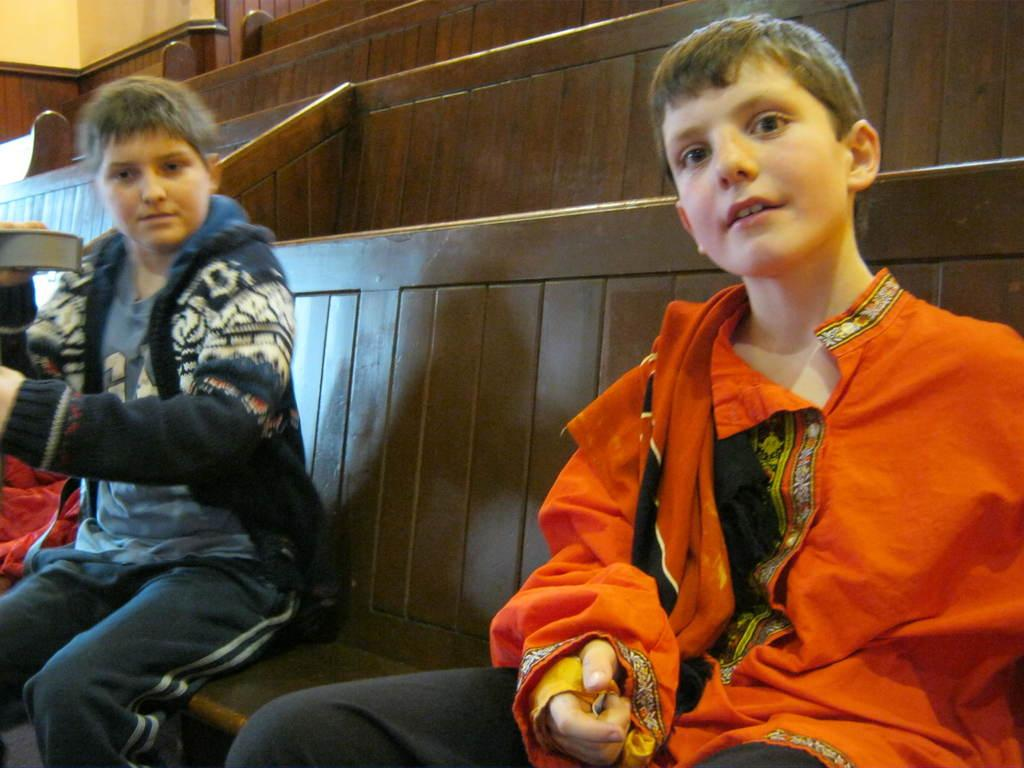How many boys are in the image? There are two boys in the image. What are the boys doing in the image? The boys are sitting on a bench. Is one of the boys holding anything? Yes, one of the boys is holding an object. What can be seen in the background of the image? There are additional benches in the background of the image. What type of net can be seen in the image? There is no net present in the image. Can you see any ducks in the image? No, there are no ducks present in the image. 